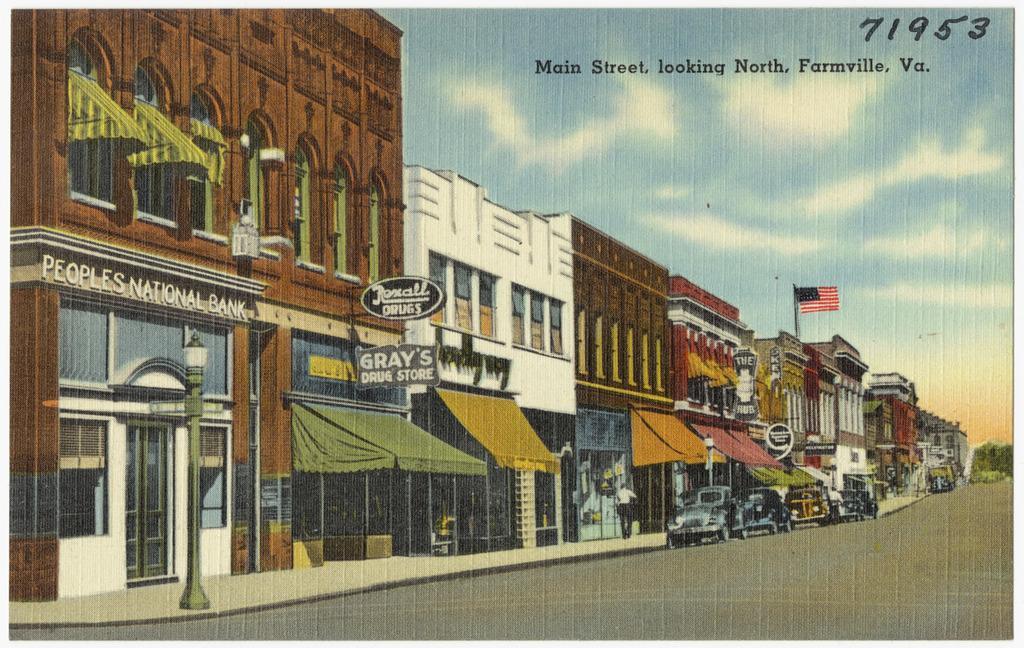How would you summarize this image in a sentence or two? This is an animated image in which there are buildings, cars and boards with some text written on it and there is a flag and the sky is cloudy and there are trees. 